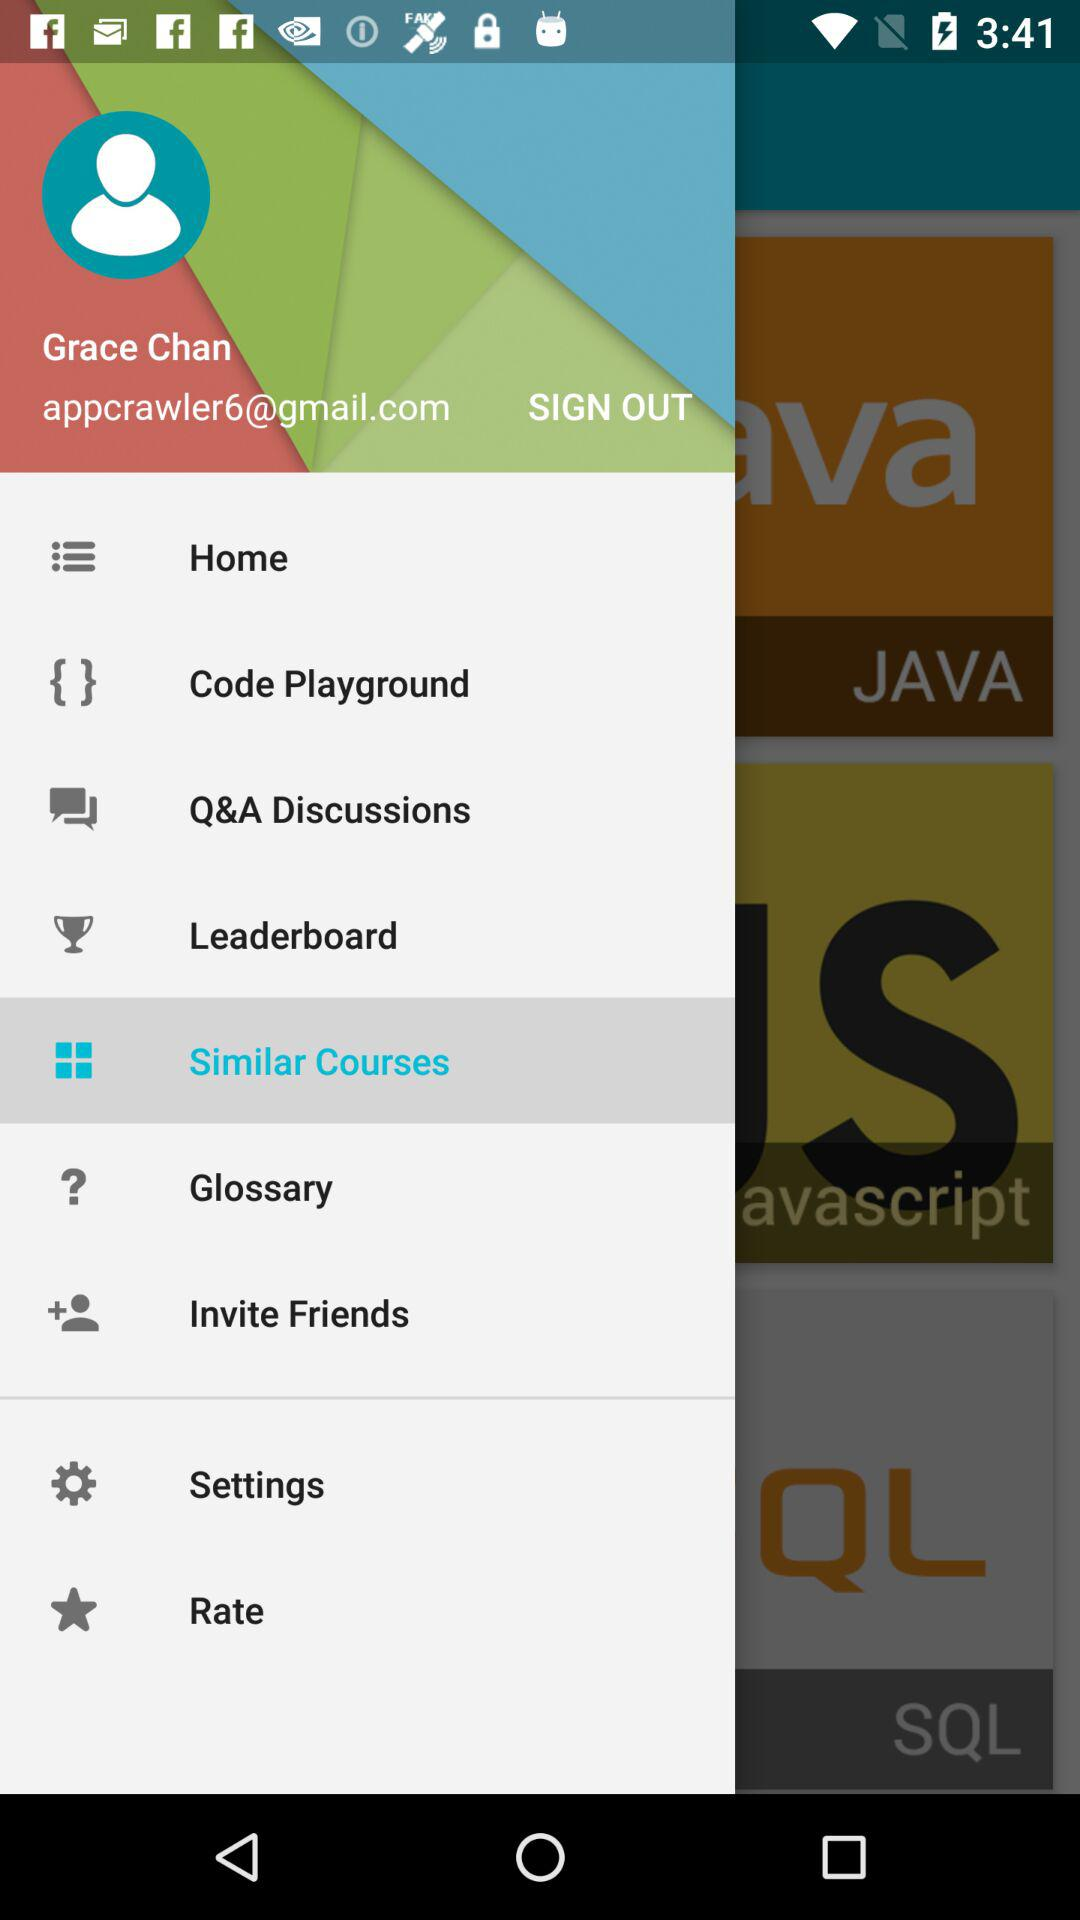What is the provided email address? The provided email address is appcrawler6@gmail.com. 